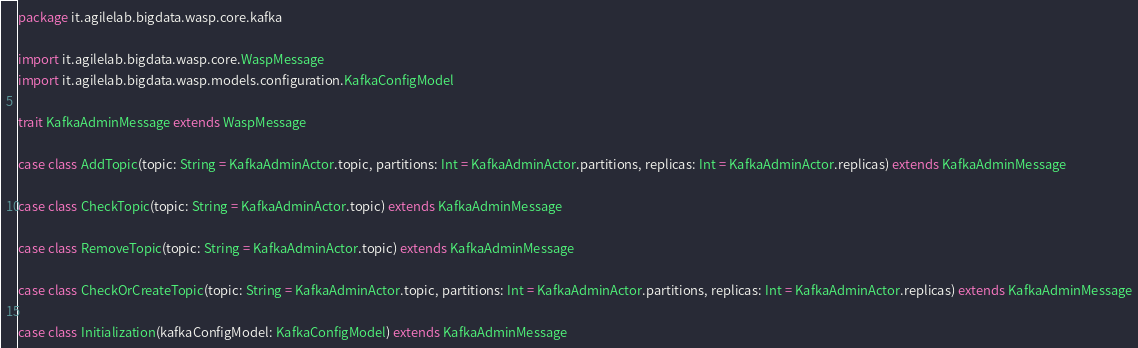<code> <loc_0><loc_0><loc_500><loc_500><_Scala_>package it.agilelab.bigdata.wasp.core.kafka

import it.agilelab.bigdata.wasp.core.WaspMessage
import it.agilelab.bigdata.wasp.models.configuration.KafkaConfigModel

trait KafkaAdminMessage extends WaspMessage

case class AddTopic(topic: String = KafkaAdminActor.topic, partitions: Int = KafkaAdminActor.partitions, replicas: Int = KafkaAdminActor.replicas) extends KafkaAdminMessage

case class CheckTopic(topic: String = KafkaAdminActor.topic) extends KafkaAdminMessage

case class RemoveTopic(topic: String = KafkaAdminActor.topic) extends KafkaAdminMessage

case class CheckOrCreateTopic(topic: String = KafkaAdminActor.topic, partitions: Int = KafkaAdminActor.partitions, replicas: Int = KafkaAdminActor.replicas) extends KafkaAdminMessage

case class Initialization(kafkaConfigModel: KafkaConfigModel) extends KafkaAdminMessage</code> 